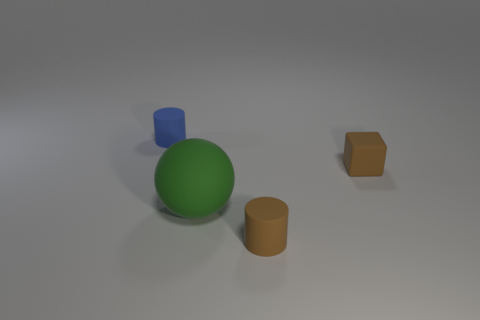Is the number of tiny blue cylinders that are on the left side of the green rubber object less than the number of brown objects that are left of the blue thing?
Your response must be concise. No. Is the shape of the small brown rubber object on the left side of the tiny brown matte cube the same as the small brown rubber thing behind the big rubber sphere?
Provide a succinct answer. No. There is a brown thing that is behind the tiny matte cylinder that is to the right of the green matte thing; what is its shape?
Offer a very short reply. Cube. What size is the cylinder that is the same color as the rubber cube?
Your answer should be compact. Small. Is there a small blue ball made of the same material as the small block?
Provide a short and direct response. No. There is a cylinder in front of the rubber sphere; what is it made of?
Your answer should be very brief. Rubber. What is the material of the small brown cylinder?
Provide a succinct answer. Rubber. Are the cylinder behind the tiny brown matte cylinder and the big object made of the same material?
Provide a short and direct response. Yes. Are there fewer small blue rubber objects that are to the right of the large thing than tiny blue matte objects?
Ensure brevity in your answer.  Yes. The matte cube that is the same size as the brown cylinder is what color?
Your answer should be very brief. Brown. 